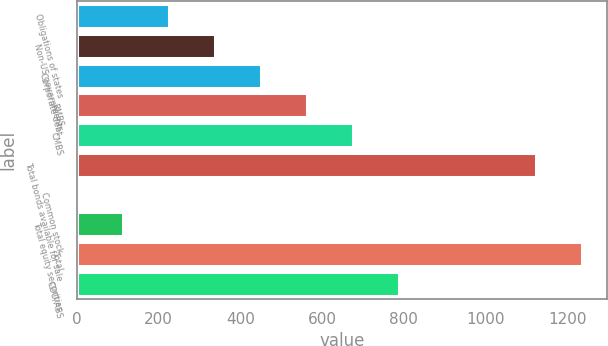Convert chart to OTSL. <chart><loc_0><loc_0><loc_500><loc_500><bar_chart><fcel>Obligations of states<fcel>Non-US governments<fcel>Corporate debt<fcel>RMBS<fcel>CMBS<fcel>Total bonds available for sale<fcel>Common stock<fcel>Total equity securities<fcel>Total<fcel>CDO/ABS<nl><fcel>225.8<fcel>338.2<fcel>450.6<fcel>563<fcel>675.4<fcel>1124<fcel>1<fcel>113.4<fcel>1236.4<fcel>787.8<nl></chart> 